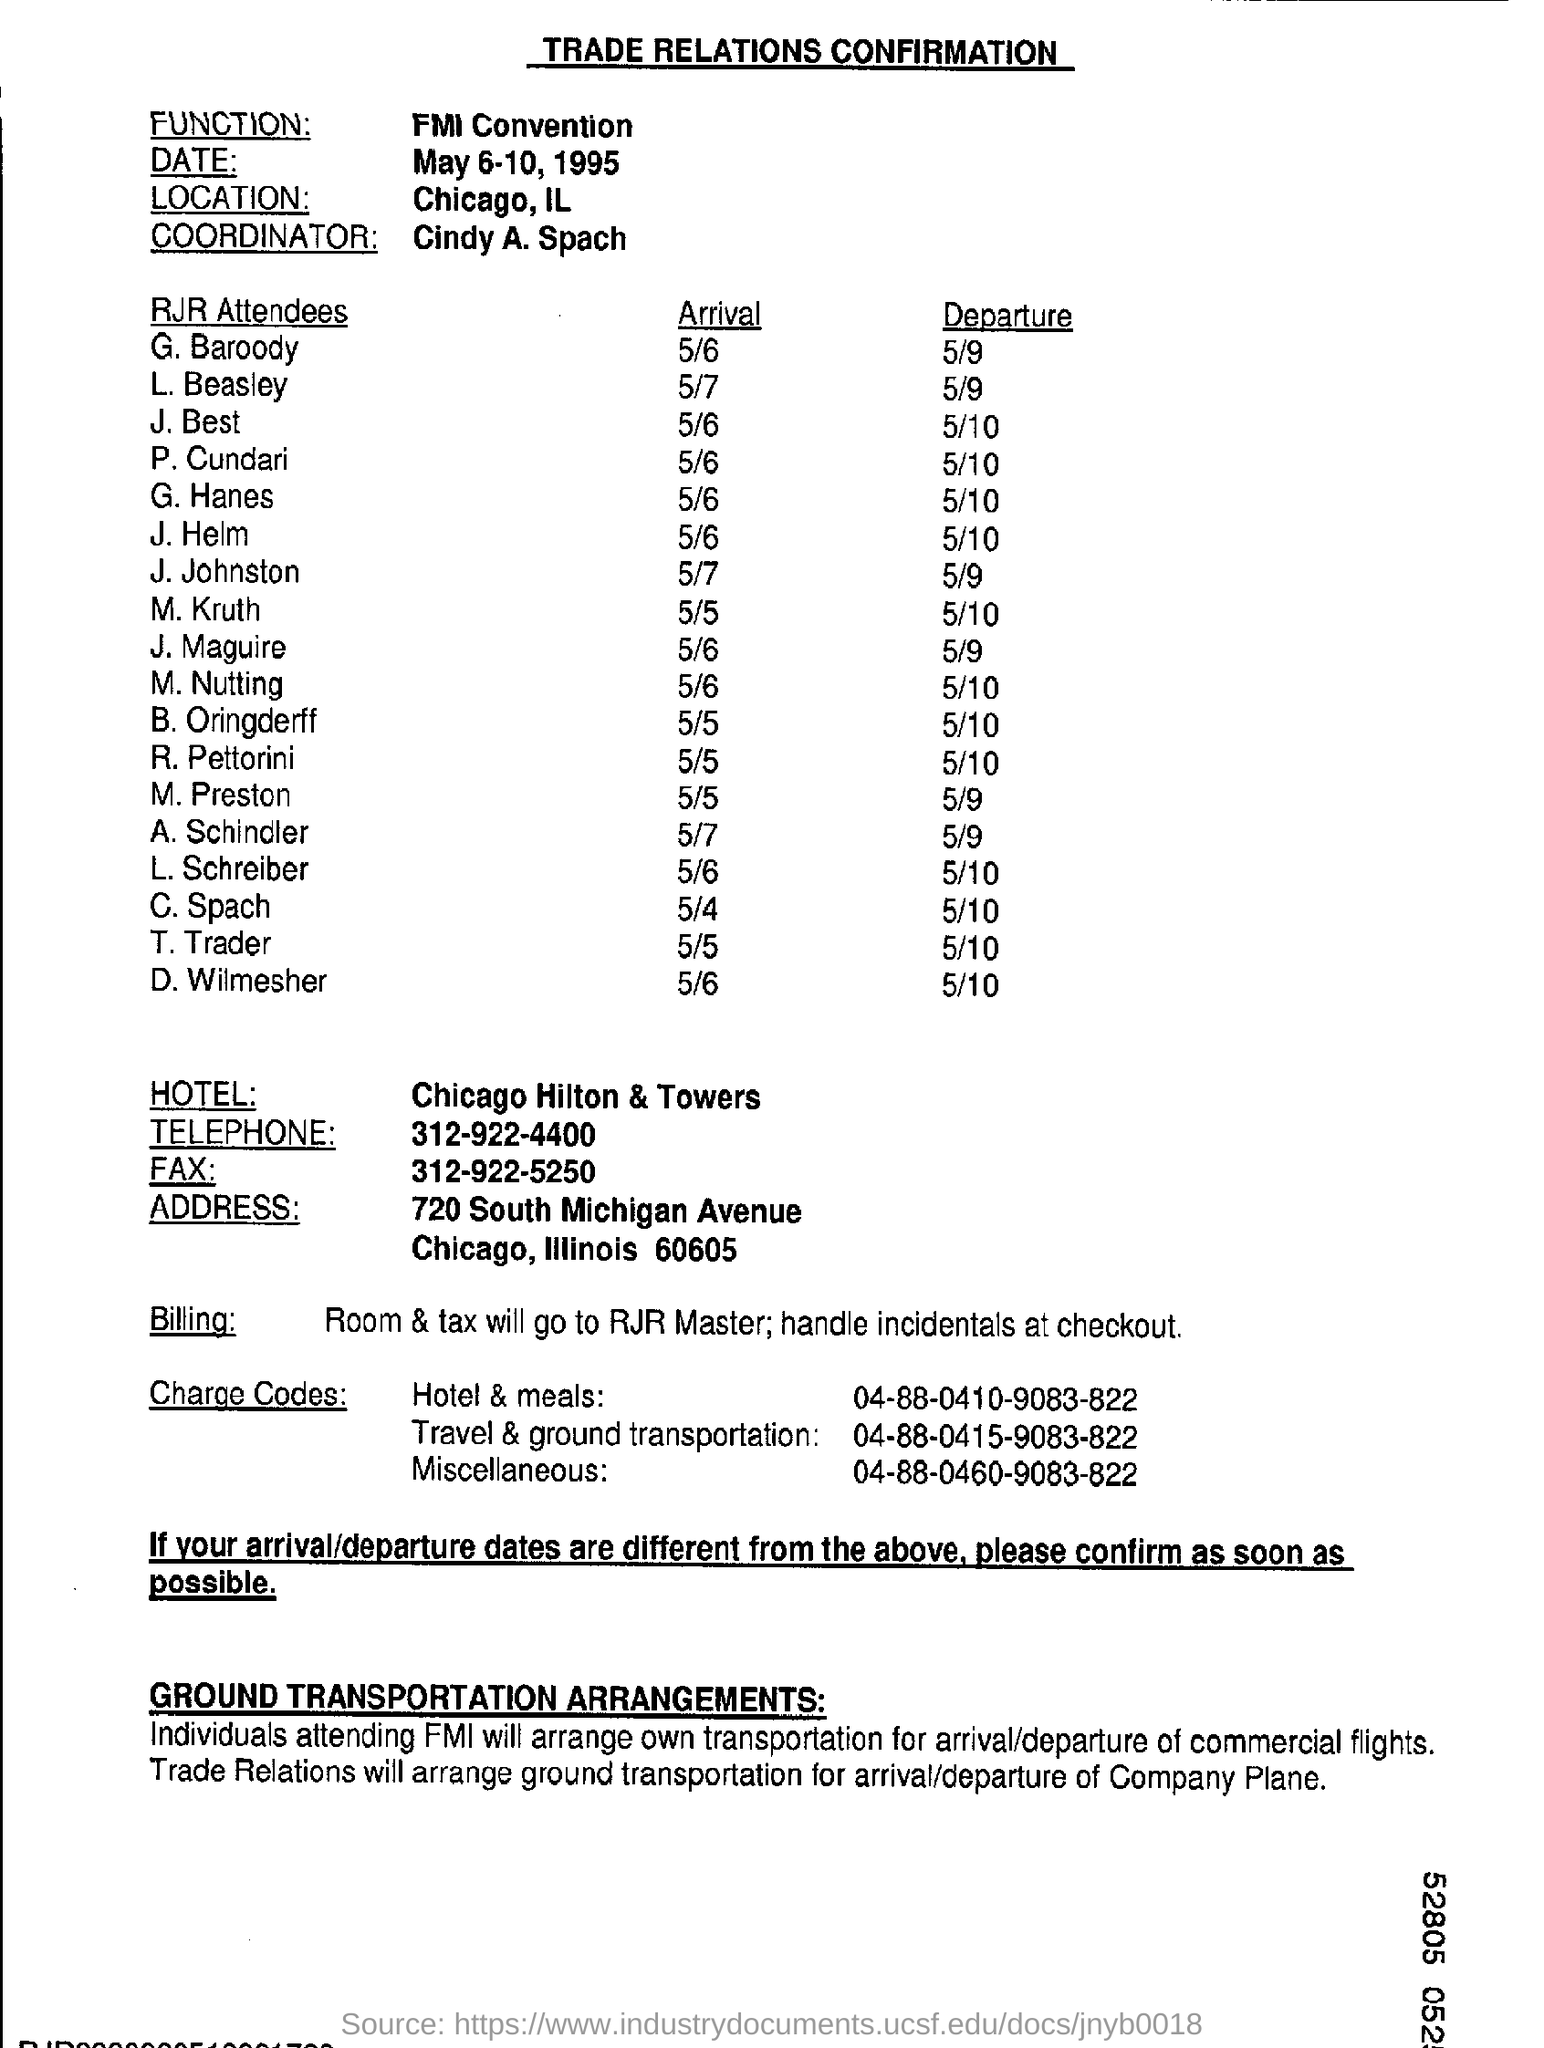Who is the coordinator ?
Your response must be concise. Cindy A. Spach. What is the name of the hotel ?
Offer a very short reply. Chicago Hilton & Towers. What is the charge code for hotel & meals ?
Your response must be concise. 04-88-0410-9083-822. What is the charge code for Miscellaneous ?
Make the answer very short. 04-88-0460-9083-822. What is the arrival date of T. Trader ?
Your response must be concise. 5/5. 